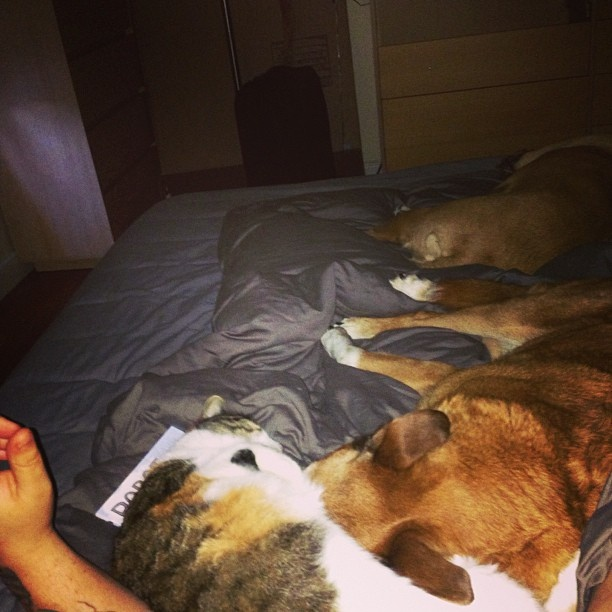Describe the objects in this image and their specific colors. I can see bed in black, gray, and maroon tones, dog in black, brown, and maroon tones, cat in black, lightgray, maroon, and gray tones, dog in black, maroon, and gray tones, and people in black, orange, brown, and red tones in this image. 